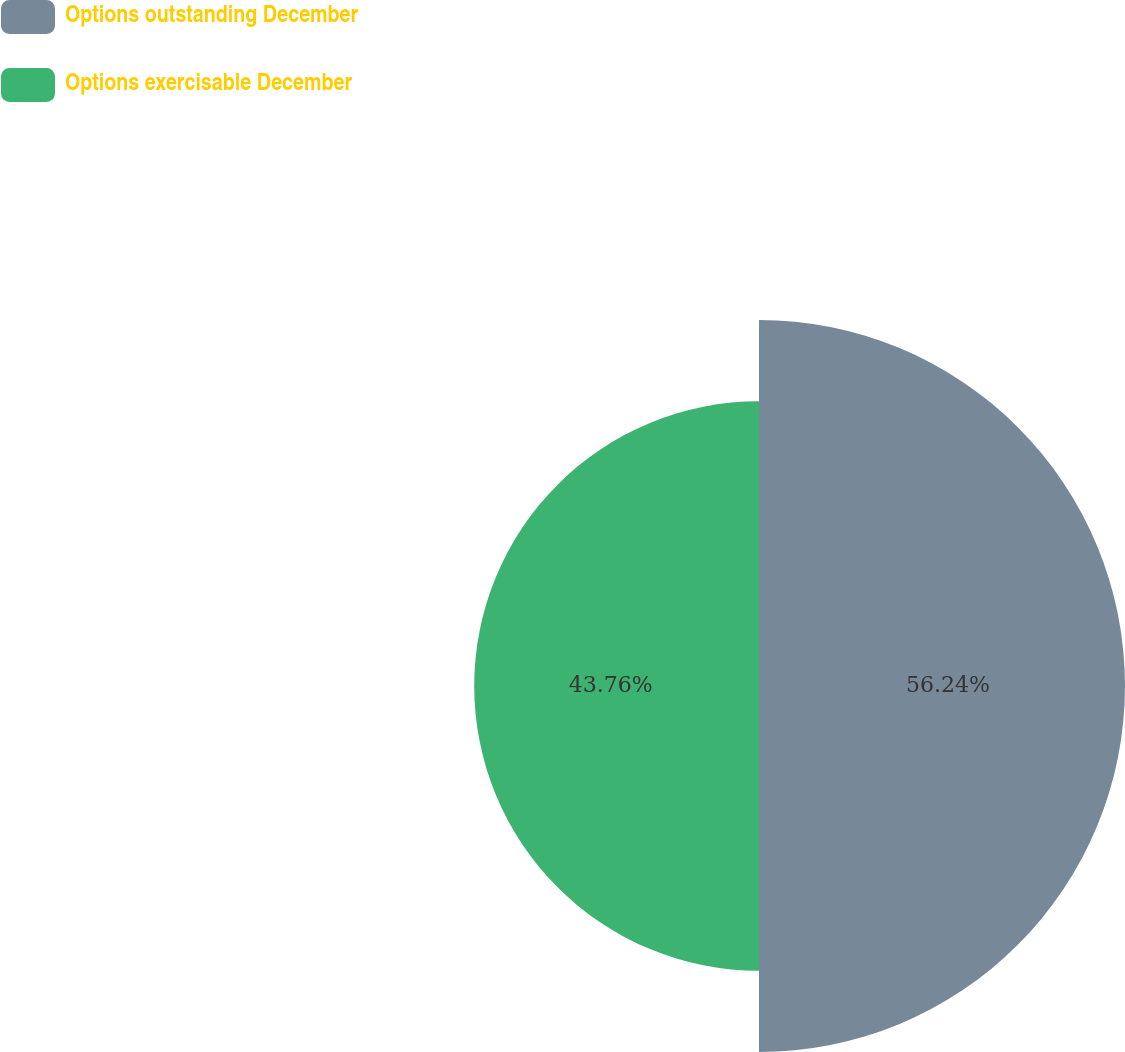Convert chart. <chart><loc_0><loc_0><loc_500><loc_500><pie_chart><fcel>Options outstanding December<fcel>Options exercisable December<nl><fcel>56.24%<fcel>43.76%<nl></chart> 